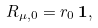Convert formula to latex. <formula><loc_0><loc_0><loc_500><loc_500>R _ { \mu , 0 } = r _ { 0 } \, { \mathbf 1 } ,</formula> 